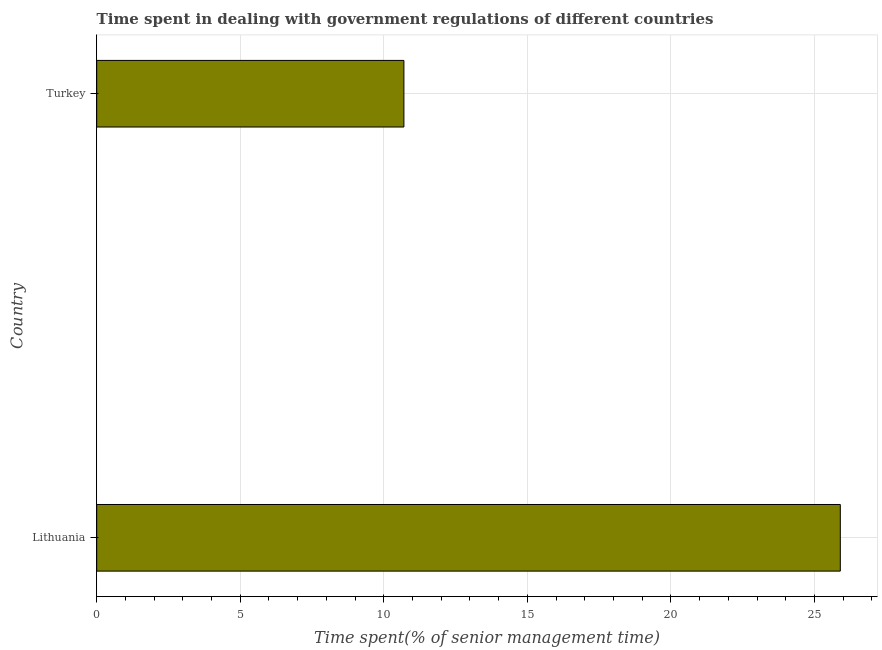Does the graph contain any zero values?
Your answer should be very brief. No. What is the title of the graph?
Provide a short and direct response. Time spent in dealing with government regulations of different countries. What is the label or title of the X-axis?
Your response must be concise. Time spent(% of senior management time). What is the time spent in dealing with government regulations in Lithuania?
Offer a terse response. 25.9. Across all countries, what is the maximum time spent in dealing with government regulations?
Keep it short and to the point. 25.9. In which country was the time spent in dealing with government regulations maximum?
Offer a very short reply. Lithuania. In which country was the time spent in dealing with government regulations minimum?
Your answer should be very brief. Turkey. What is the sum of the time spent in dealing with government regulations?
Ensure brevity in your answer.  36.6. What is the difference between the time spent in dealing with government regulations in Lithuania and Turkey?
Your answer should be compact. 15.2. What is the median time spent in dealing with government regulations?
Keep it short and to the point. 18.3. In how many countries, is the time spent in dealing with government regulations greater than 12 %?
Offer a very short reply. 1. What is the ratio of the time spent in dealing with government regulations in Lithuania to that in Turkey?
Offer a very short reply. 2.42. Are all the bars in the graph horizontal?
Give a very brief answer. Yes. What is the difference between two consecutive major ticks on the X-axis?
Your answer should be very brief. 5. What is the Time spent(% of senior management time) of Lithuania?
Offer a very short reply. 25.9. What is the Time spent(% of senior management time) of Turkey?
Your response must be concise. 10.7. What is the difference between the Time spent(% of senior management time) in Lithuania and Turkey?
Keep it short and to the point. 15.2. What is the ratio of the Time spent(% of senior management time) in Lithuania to that in Turkey?
Keep it short and to the point. 2.42. 